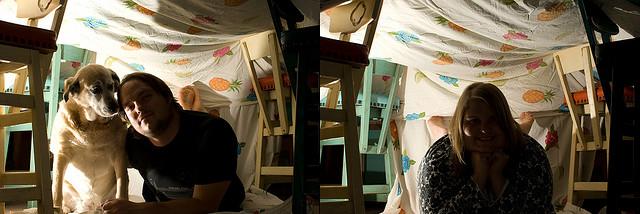Are both of the people men?
Concise answer only. No. What type of dog is this?
Give a very brief answer. Lab. Does the man like dogs?
Short answer required. Yes. 